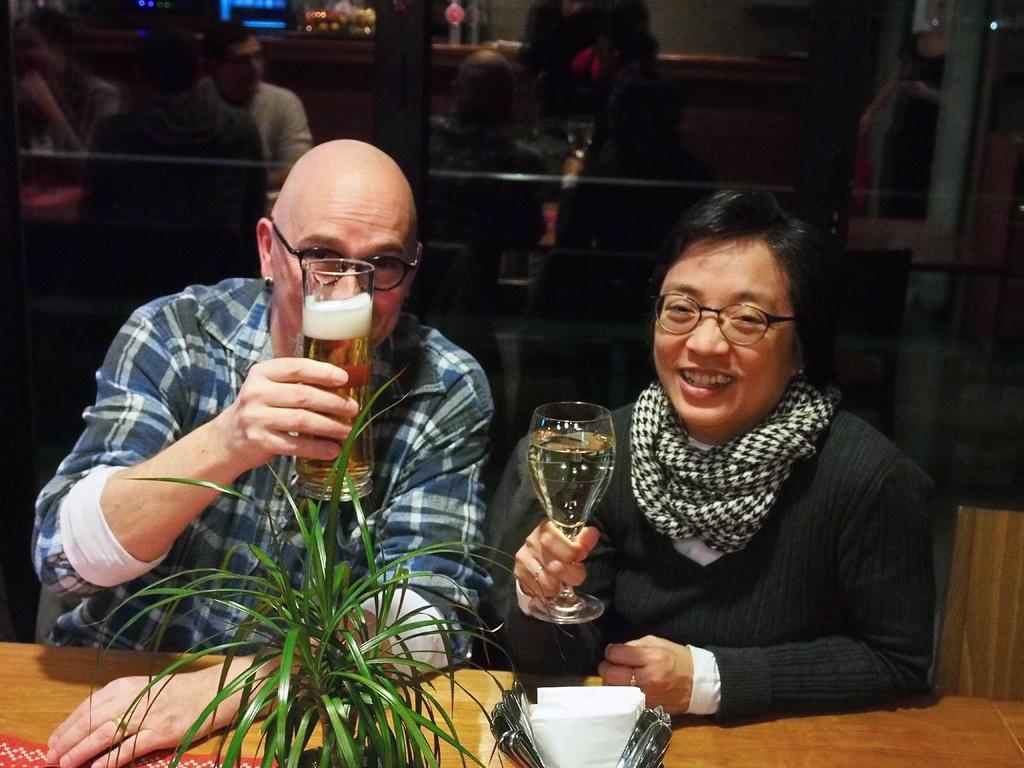In one or two sentences, can you explain what this image depicts? It seems to be the image is inside the restaurant. In the image there are two people, man and woman are sitting on chair in front of a table. On table we can see a plant,tissues,mat in background there is a glass door inside a glass door we can see group of people sitting on chair. 